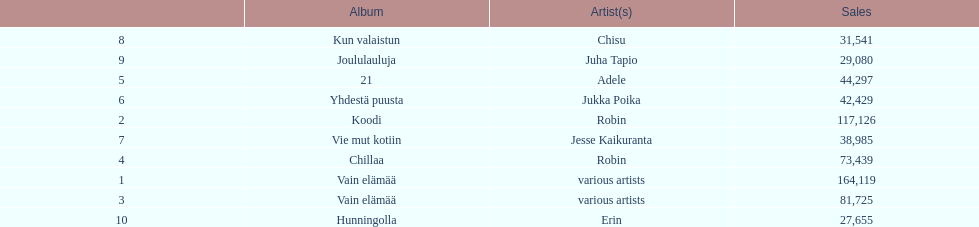What is the total number of sales for the top 10 albums? 650396. 